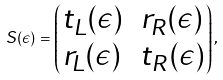<formula> <loc_0><loc_0><loc_500><loc_500>S ( \epsilon ) = \begin{pmatrix} t _ { L } ( \epsilon ) & r _ { R } ( \epsilon ) \\ r _ { L } ( \epsilon ) & t _ { R } ( \epsilon ) \end{pmatrix} ,</formula> 